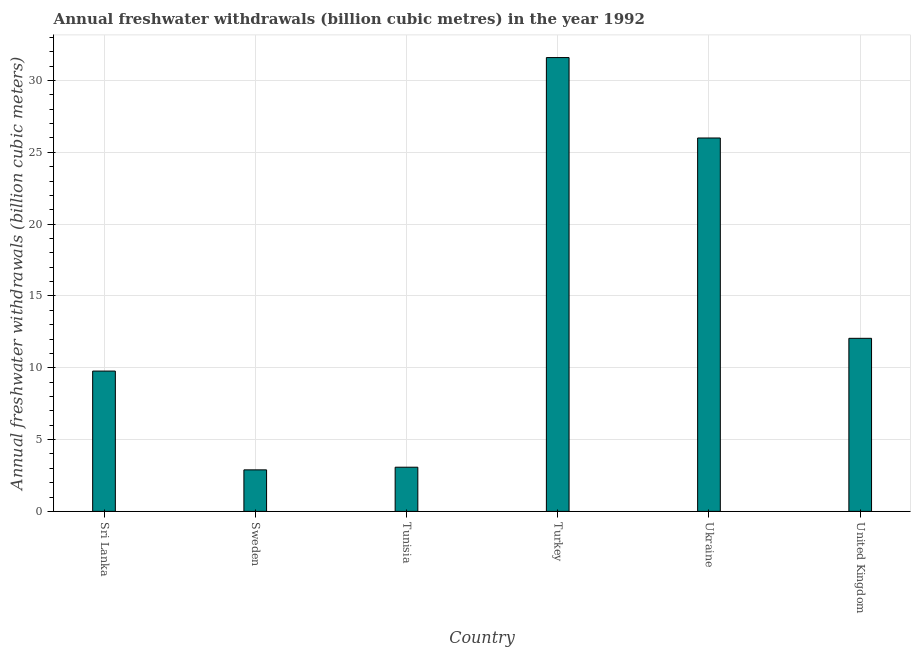What is the title of the graph?
Your answer should be compact. Annual freshwater withdrawals (billion cubic metres) in the year 1992. What is the label or title of the X-axis?
Your answer should be compact. Country. What is the label or title of the Y-axis?
Your response must be concise. Annual freshwater withdrawals (billion cubic meters). What is the annual freshwater withdrawals in Turkey?
Make the answer very short. 31.6. Across all countries, what is the maximum annual freshwater withdrawals?
Your response must be concise. 31.6. Across all countries, what is the minimum annual freshwater withdrawals?
Provide a short and direct response. 2.89. In which country was the annual freshwater withdrawals maximum?
Make the answer very short. Turkey. In which country was the annual freshwater withdrawals minimum?
Make the answer very short. Sweden. What is the sum of the annual freshwater withdrawals?
Offer a very short reply. 85.38. What is the difference between the annual freshwater withdrawals in Sweden and Turkey?
Provide a short and direct response. -28.71. What is the average annual freshwater withdrawals per country?
Give a very brief answer. 14.23. What is the median annual freshwater withdrawals?
Offer a very short reply. 10.91. What is the ratio of the annual freshwater withdrawals in Ukraine to that in United Kingdom?
Ensure brevity in your answer.  2.16. Is the annual freshwater withdrawals in Tunisia less than that in Turkey?
Keep it short and to the point. Yes. Is the difference between the annual freshwater withdrawals in Turkey and Ukraine greater than the difference between any two countries?
Ensure brevity in your answer.  No. Is the sum of the annual freshwater withdrawals in Sri Lanka and Tunisia greater than the maximum annual freshwater withdrawals across all countries?
Keep it short and to the point. No. What is the difference between the highest and the lowest annual freshwater withdrawals?
Ensure brevity in your answer.  28.71. In how many countries, is the annual freshwater withdrawals greater than the average annual freshwater withdrawals taken over all countries?
Provide a succinct answer. 2. How many bars are there?
Give a very brief answer. 6. Are the values on the major ticks of Y-axis written in scientific E-notation?
Ensure brevity in your answer.  No. What is the Annual freshwater withdrawals (billion cubic meters) in Sri Lanka?
Make the answer very short. 9.77. What is the Annual freshwater withdrawals (billion cubic meters) of Sweden?
Make the answer very short. 2.89. What is the Annual freshwater withdrawals (billion cubic meters) in Tunisia?
Keep it short and to the point. 3.08. What is the Annual freshwater withdrawals (billion cubic meters) in Turkey?
Your response must be concise. 31.6. What is the Annual freshwater withdrawals (billion cubic meters) of United Kingdom?
Give a very brief answer. 12.05. What is the difference between the Annual freshwater withdrawals (billion cubic meters) in Sri Lanka and Sweden?
Provide a short and direct response. 6.88. What is the difference between the Annual freshwater withdrawals (billion cubic meters) in Sri Lanka and Tunisia?
Ensure brevity in your answer.  6.69. What is the difference between the Annual freshwater withdrawals (billion cubic meters) in Sri Lanka and Turkey?
Make the answer very short. -21.83. What is the difference between the Annual freshwater withdrawals (billion cubic meters) in Sri Lanka and Ukraine?
Offer a terse response. -16.23. What is the difference between the Annual freshwater withdrawals (billion cubic meters) in Sri Lanka and United Kingdom?
Your answer should be compact. -2.28. What is the difference between the Annual freshwater withdrawals (billion cubic meters) in Sweden and Tunisia?
Provide a short and direct response. -0.18. What is the difference between the Annual freshwater withdrawals (billion cubic meters) in Sweden and Turkey?
Keep it short and to the point. -28.71. What is the difference between the Annual freshwater withdrawals (billion cubic meters) in Sweden and Ukraine?
Your answer should be compact. -23.11. What is the difference between the Annual freshwater withdrawals (billion cubic meters) in Sweden and United Kingdom?
Make the answer very short. -9.16. What is the difference between the Annual freshwater withdrawals (billion cubic meters) in Tunisia and Turkey?
Ensure brevity in your answer.  -28.52. What is the difference between the Annual freshwater withdrawals (billion cubic meters) in Tunisia and Ukraine?
Your answer should be very brief. -22.93. What is the difference between the Annual freshwater withdrawals (billion cubic meters) in Tunisia and United Kingdom?
Your answer should be very brief. -8.97. What is the difference between the Annual freshwater withdrawals (billion cubic meters) in Turkey and Ukraine?
Your answer should be compact. 5.6. What is the difference between the Annual freshwater withdrawals (billion cubic meters) in Turkey and United Kingdom?
Give a very brief answer. 19.55. What is the difference between the Annual freshwater withdrawals (billion cubic meters) in Ukraine and United Kingdom?
Make the answer very short. 13.95. What is the ratio of the Annual freshwater withdrawals (billion cubic meters) in Sri Lanka to that in Sweden?
Give a very brief answer. 3.38. What is the ratio of the Annual freshwater withdrawals (billion cubic meters) in Sri Lanka to that in Tunisia?
Provide a succinct answer. 3.18. What is the ratio of the Annual freshwater withdrawals (billion cubic meters) in Sri Lanka to that in Turkey?
Offer a very short reply. 0.31. What is the ratio of the Annual freshwater withdrawals (billion cubic meters) in Sri Lanka to that in Ukraine?
Provide a succinct answer. 0.38. What is the ratio of the Annual freshwater withdrawals (billion cubic meters) in Sri Lanka to that in United Kingdom?
Your answer should be compact. 0.81. What is the ratio of the Annual freshwater withdrawals (billion cubic meters) in Sweden to that in Tunisia?
Ensure brevity in your answer.  0.94. What is the ratio of the Annual freshwater withdrawals (billion cubic meters) in Sweden to that in Turkey?
Offer a terse response. 0.09. What is the ratio of the Annual freshwater withdrawals (billion cubic meters) in Sweden to that in Ukraine?
Give a very brief answer. 0.11. What is the ratio of the Annual freshwater withdrawals (billion cubic meters) in Sweden to that in United Kingdom?
Make the answer very short. 0.24. What is the ratio of the Annual freshwater withdrawals (billion cubic meters) in Tunisia to that in Turkey?
Give a very brief answer. 0.1. What is the ratio of the Annual freshwater withdrawals (billion cubic meters) in Tunisia to that in Ukraine?
Ensure brevity in your answer.  0.12. What is the ratio of the Annual freshwater withdrawals (billion cubic meters) in Tunisia to that in United Kingdom?
Your answer should be very brief. 0.26. What is the ratio of the Annual freshwater withdrawals (billion cubic meters) in Turkey to that in Ukraine?
Ensure brevity in your answer.  1.22. What is the ratio of the Annual freshwater withdrawals (billion cubic meters) in Turkey to that in United Kingdom?
Make the answer very short. 2.62. What is the ratio of the Annual freshwater withdrawals (billion cubic meters) in Ukraine to that in United Kingdom?
Offer a terse response. 2.16. 